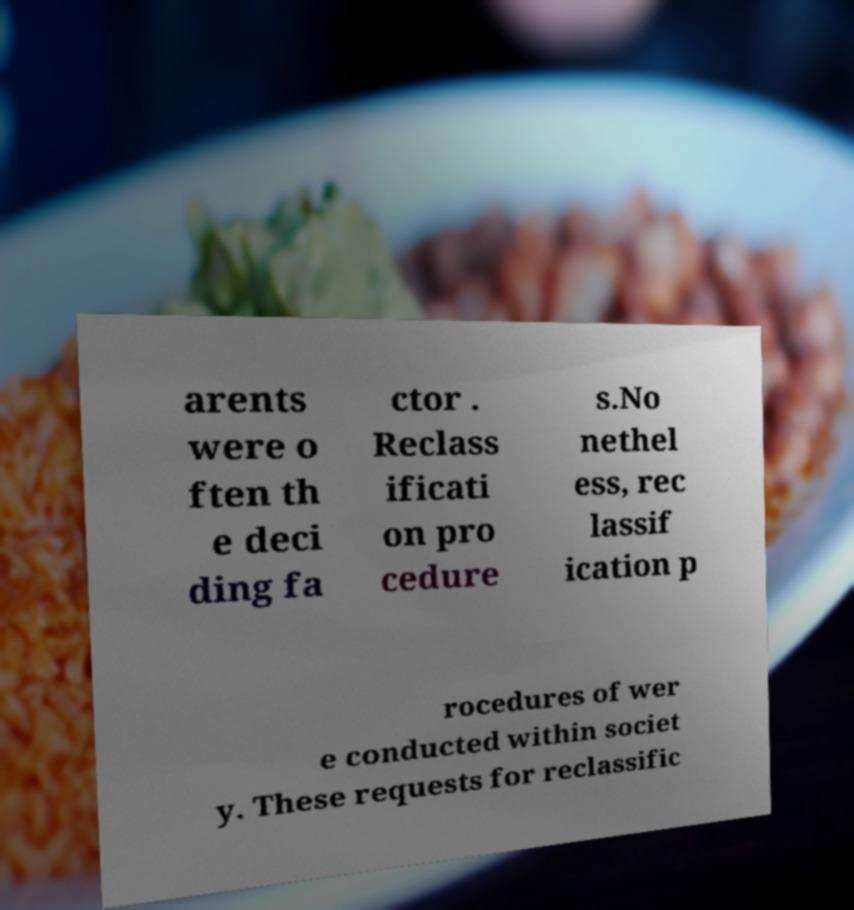Please read and relay the text visible in this image. What does it say? arents were o ften th e deci ding fa ctor . Reclass ificati on pro cedure s.No nethel ess, rec lassif ication p rocedures of wer e conducted within societ y. These requests for reclassific 